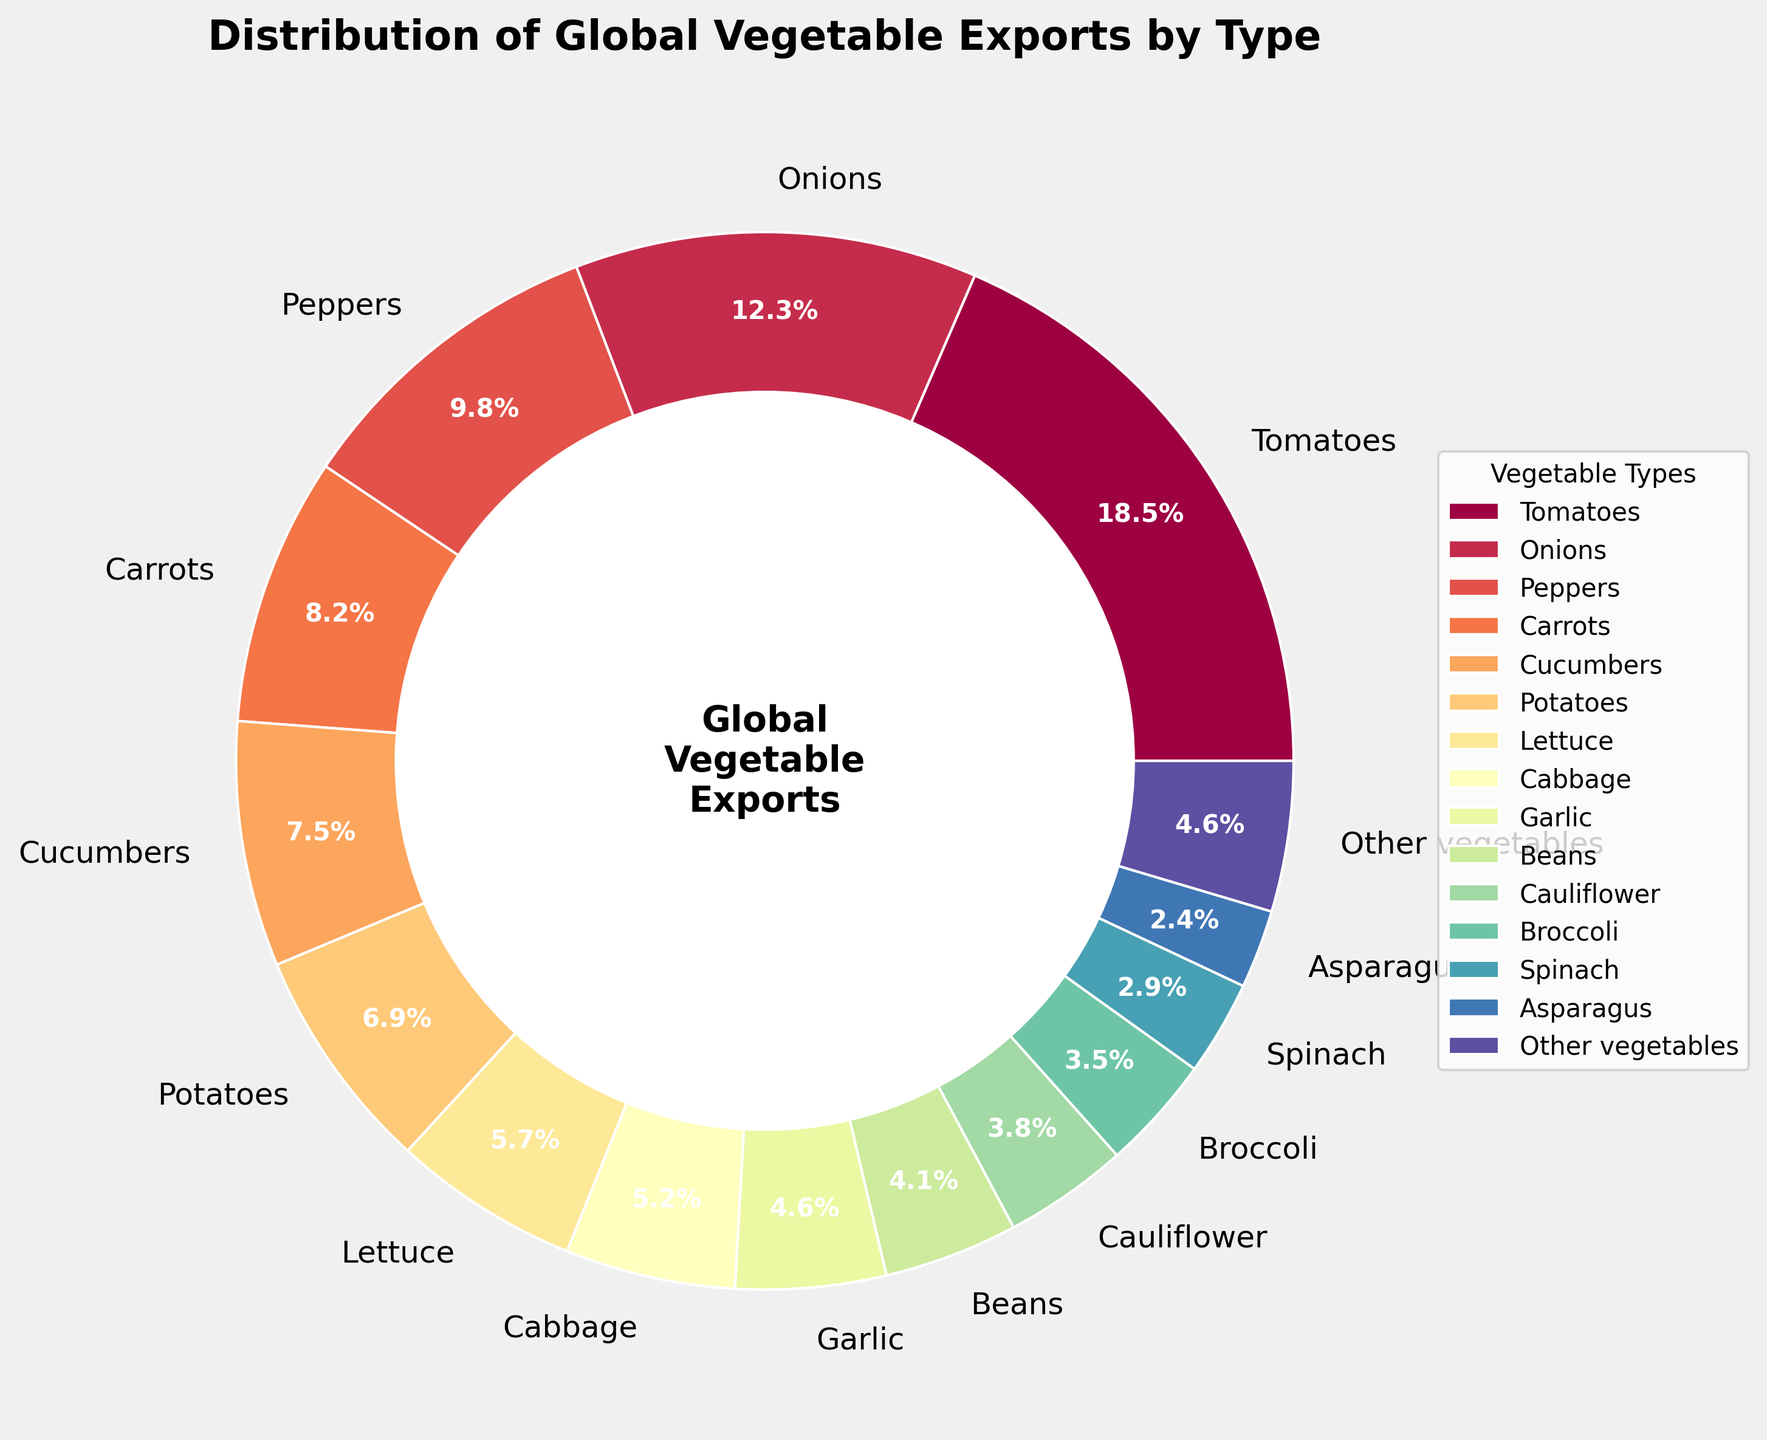What percentage of total global vegetable exports is comprised of tomatoes and onions combined? First, find the percentages for tomatoes (18.5%) and onions (12.3%). Add these two percentages together: 18.5% + 12.3% = 30.8%.
Answer: 30.8% Which type of vegetable export comes immediately after tomatoes in terms of percentage? Tomatoes have the highest percentage at 18.5%. The next highest percentage after tomatoes is onions, which have a percentage of 12.3%.
Answer: Onions How much higher is the percentage of pepper exports compared to broccoli exports? Find the percentages for peppers (9.8%) and broccoli (3.5%). Subtract the percentage of broccoli from the percentage of peppers: 9.8% - 3.5% = 6.3%.
Answer: 6.3% What is the difference in percentage between the vegetable with the lowest export value and the one with the highest export value? The vegetable with the highest export value is tomatoes (18.5%) and the one with the lowest is asparagus (2.4%). Subtract the lowest percentage from the highest percentage: 18.5% - 2.4% = 16.1%.
Answer: 16.1% Which vegetable exports are represented by the smallest wedge in the pie chart? The smallest wedge in the pie chart is for the vegetable with the lowest percentage, which is asparagus at 2.4%.
Answer: Asparagus How do the combined percentages of leafy vegetables (lettuce, cabbage, spinach) compare to the percentage of tomatoes? Sum the percentages of lettuce, cabbage, and spinach (5.7% + 5.2% + 2.9% = 13.8%). Compare this combined percentage to that of tomatoes, which is 18.5%. 13.8% is less than 18.5%.
Answer: Less than Which vegetable type has an equal export percentage to garlic? The percentage of garlic is 4.6%. The type with an equal percentage is "other vegetables," which also has a percentage of 4.6%.
Answer: Other vegetables Which vegetable exports are higher, beans or cauliflower? By what percentage? The percentage of beans is 4.1%, and the percentage of cauliflower is 3.8%. Beans have a higher percentage. The difference is 4.1% - 3.8% = 0.3%.
Answer: Beans; 0.3% What is the combined percentage of exports for cucumbers, potatoes, and lettuce? Sum the percentages of cucumbers (7.5%), potatoes (6.9%), and lettuce (5.7%): 7.5% + 6.9% + 5.7% = 20.1%.
Answer: 20.1% 